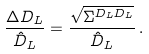<formula> <loc_0><loc_0><loc_500><loc_500>\frac { \Delta D _ { L } } { \hat { D } _ { L } } = \frac { \sqrt { \Sigma ^ { D _ { L } D _ { L } } } } { \hat { D } _ { L } } \, .</formula> 